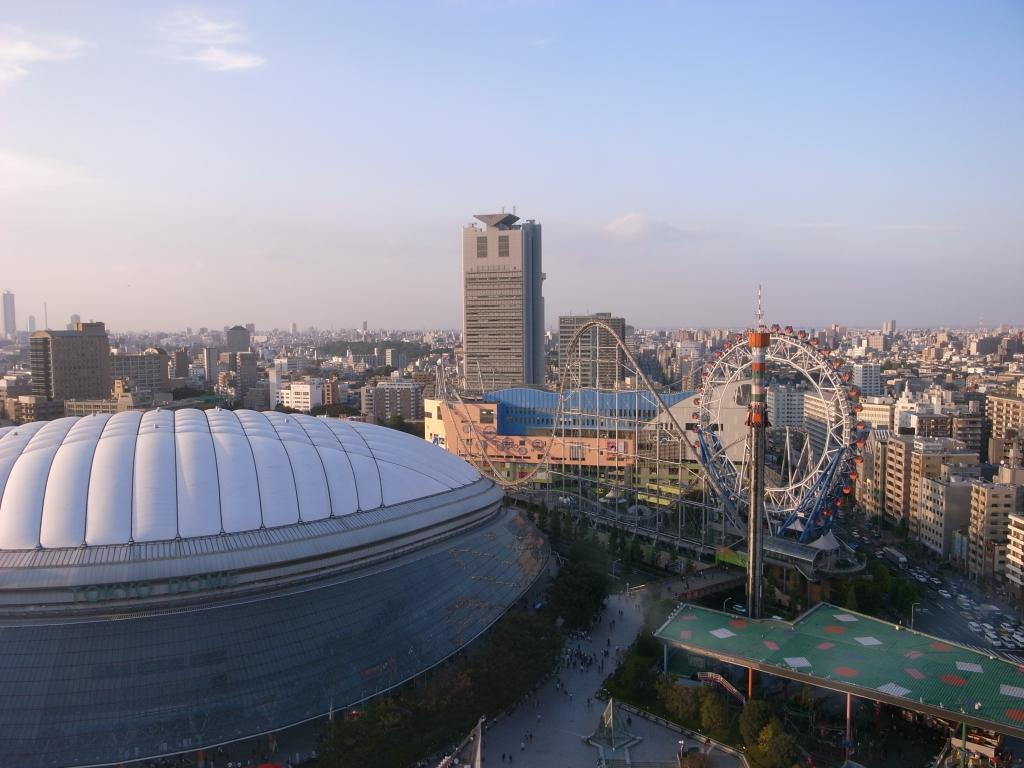What type of structures can be seen in the image? There are buildings in the image. What mechanical object is visible in the image? A joint wheel is visible in the image. What type of vegetation is present in the image? There are trees in the image. What type of transportation is present in the image? Vehicles are present on the road in the image. Who or what is present in the image besides the buildings and vehicles? There is a group of people in the image. What can be seen in the background of the image? The sky with clouds is visible in the background of the image. What type of light is being used to illuminate the tray in the image? There is no tray present in the image, so it is not possible to determine what type of light is being used to illuminate it. 